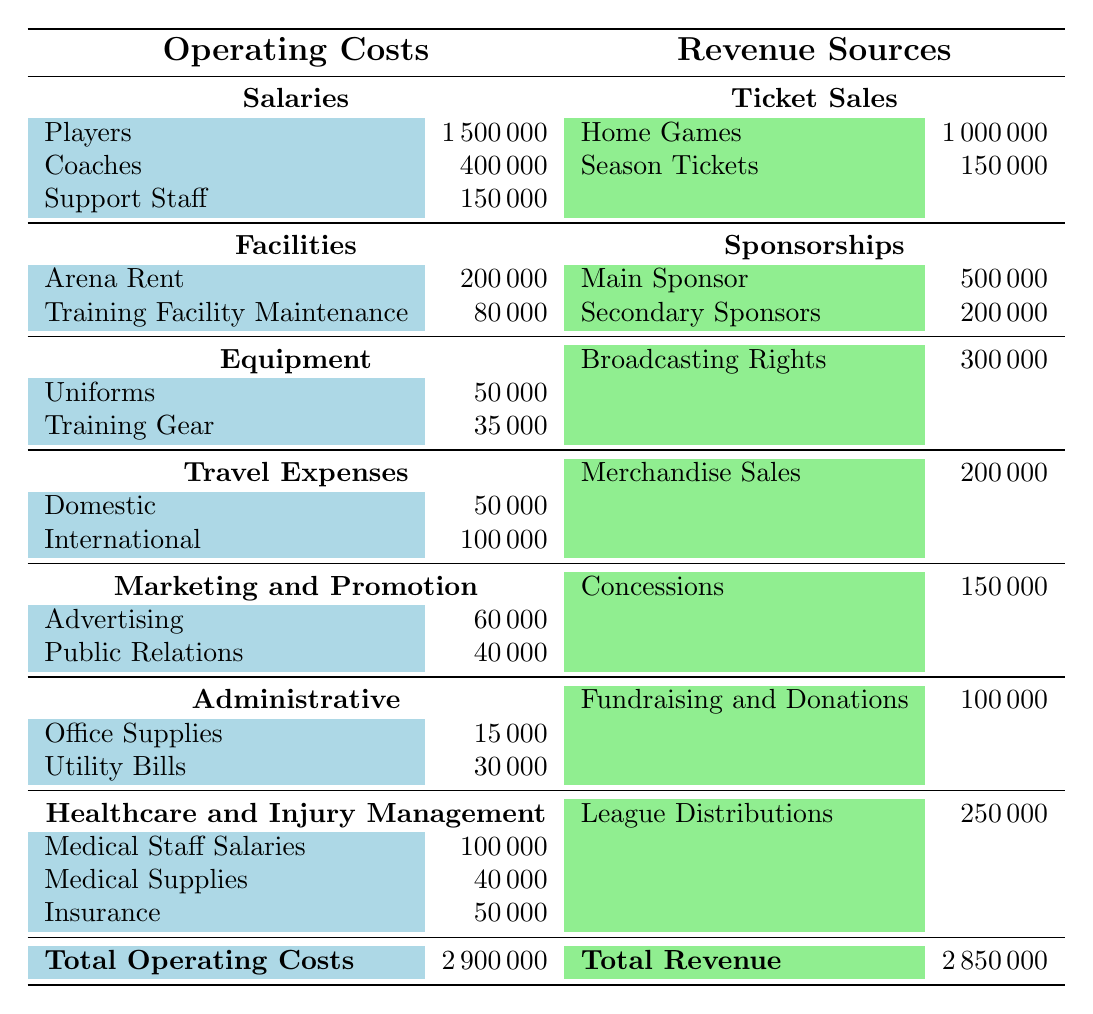What is the total operating cost for the basketball team? To find the total operating costs, we add all individual cost components: salaries (1,500,000 + 400,000 + 150,000) + facilities (200,000 + 80,000) + equipment (50,000 + 35,000) + travel expenses (50,000 + 100,000) + marketing (60,000 + 40,000) + administrative (15,000 + 30,000) + healthcare (100,000 + 40,000 + 50,000). The total comes to 2,900,000.
Answer: 2,900,000 How much does the team earn from ticket sales during home games? The table shows that the revenue from ticket sales from home games is specified as 1,000,000.
Answer: 1,000,000 Is the revenue from merchandise sales greater than the revenue from concessions? The revenue from merchandise sales is 200,000, while the revenue from concessions is 150,000. Since 200,000 is greater than 150,000, the answer is yes.
Answer: Yes What is the total amount earned from sponsorships? To find the total sponsorship revenue, we sum the values for the main sponsor (500,000) and secondary sponsors (200,000). Therefore, the total amount from sponsorships is 500,000 + 200,000 = 700,000.
Answer: 700,000 What are the total healthcare and injury management costs? To find the total costs in this category, we add the medical staff salaries (100,000), medical supplies (40,000), and insurance (50,000). Thus, the total is 100,000 + 40,000 + 50,000 = 190,000.
Answer: 190,000 Is the total revenue less than the total operating costs? The total revenue is 2,850,000, which is less than the total operating costs of 2,900,000. Hence, the answer is yes.
Answer: Yes What is the difference between total revenue and total operating costs? To find the difference, we subtract total revenue (2,850,000) from total operating costs (2,900,000): 2,900,000 - 2,850,000 = 50,000.
Answer: 50,000 What percentage of the total operating costs are attributed to player salaries? To find the percentage, we first need to determine the player salaries total (1,500,000) and divide this by the total operating costs (2,900,000), then multiply by 100: (1,500,000 / 2,900,000) * 100 ≈ 51.72%. Therefore, approximately 51.72% of operating costs are from player salaries.
Answer: Approximately 51.72% 